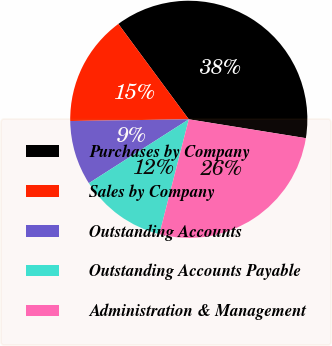<chart> <loc_0><loc_0><loc_500><loc_500><pie_chart><fcel>Purchases by Company<fcel>Sales by Company<fcel>Outstanding Accounts<fcel>Outstanding Accounts Payable<fcel>Administration & Management<nl><fcel>37.66%<fcel>15.11%<fcel>8.82%<fcel>11.96%<fcel>26.45%<nl></chart> 